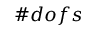<formula> <loc_0><loc_0><loc_500><loc_500>\# d o f s</formula> 